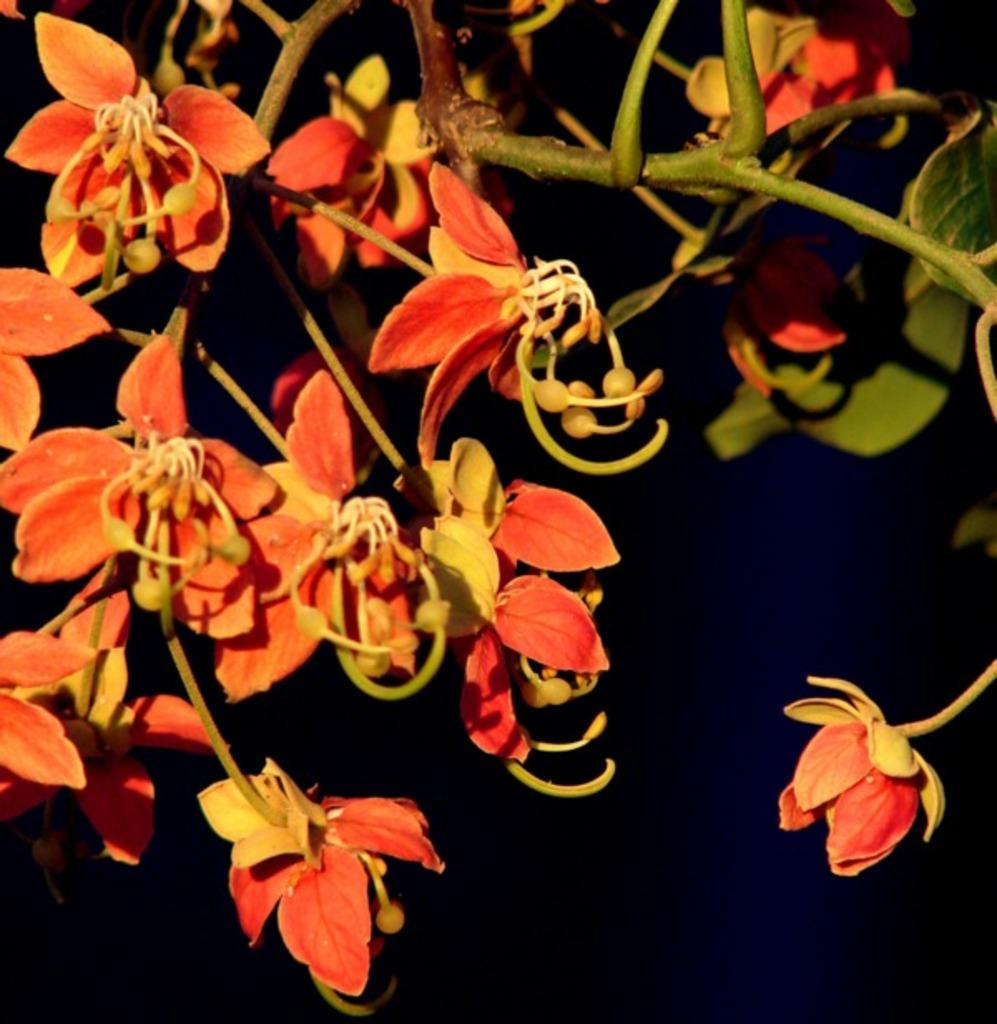What type of plant is visible in the image? There is a plant with flowers in the image. What can be observed about the background of the image? The background of the image is dark. Can you see a rat with a horn in the image? No, there is no rat or horn present in the image. The image features a plant with flowers against a dark background. 